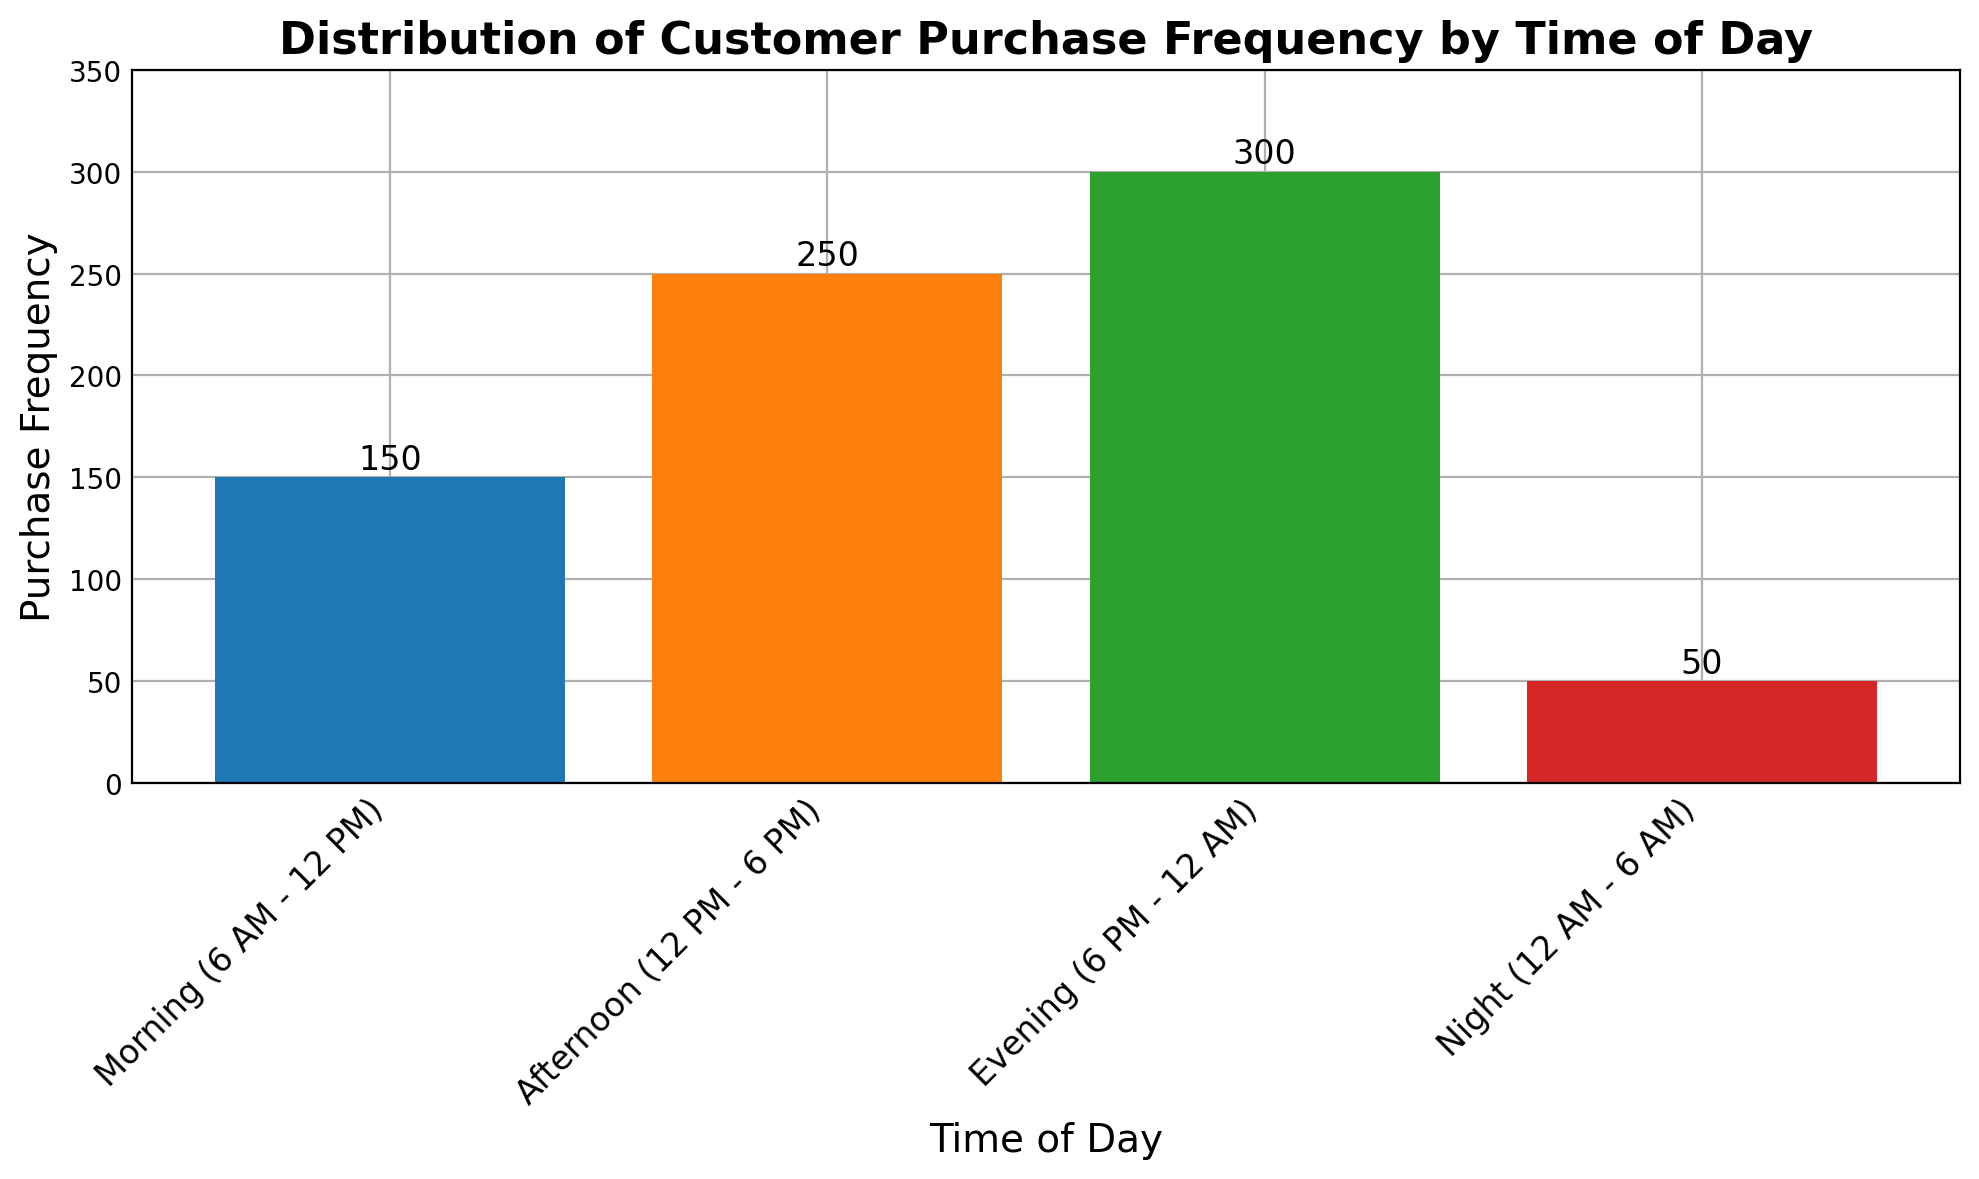What's the total purchase frequency for the entire day? Add up the purchase frequencies for all time periods: 150 (Morning) + 250 (Afternoon) + 300 (Evening) + 50 (Night) = 750
Answer: 750 Which time of day has the highest purchase frequency? Observe the height of the bars; the tallest bar represents the Evening with a frequency of 300
Answer: Evening How much more frequent is shopping in the Afternoon compared to the Morning? Subtract the Morning purchase frequency from the Afternoon purchase frequency: 250 - 150 = 100
Answer: 100 What's the average purchase frequency across all times of the day? Sum the frequencies and divide by the number of time periods: (150 + 250 + 300 + 50) / 4 = 750 / 4 = 187.5
Answer: 187.5 What's the combined purchase frequency for both the Morning and Night? Add the purchase frequencies of the Morning and Night: 150 (Morning) + 50 (Night) = 200
Answer: 200 Which time of day has the lowest purchase frequency? Observe the heights of the bars; the shortest bar represents the Night with a frequency of 50
Answer: Night Is the purchase frequency in the Evening greater than the combined total of Morning and Night? Sum the Morning and Night frequencies and compare to the Evening: Morning (150) + Night (50) = 200; Evening = 300, thus 300 > 200
Answer: Yes By how much does the Evening frequency exceed the Afternoon frequency? Subtract the Afternoon purchase frequency from the Evening purchase frequency: 300 - 250 = 50
Answer: 50 What fraction of total purchases happens in the Morning time period? Morning purchase frequency divided by total purchase frequency: 150 / 750; simplify the fraction to 1 / 5
Answer: 1/5 Which time period shows a purchase frequency that is half of the highest purchase frequency? Evening (300) is the highest; half of it is 150, which corresponds to the Morning period
Answer: Morning 